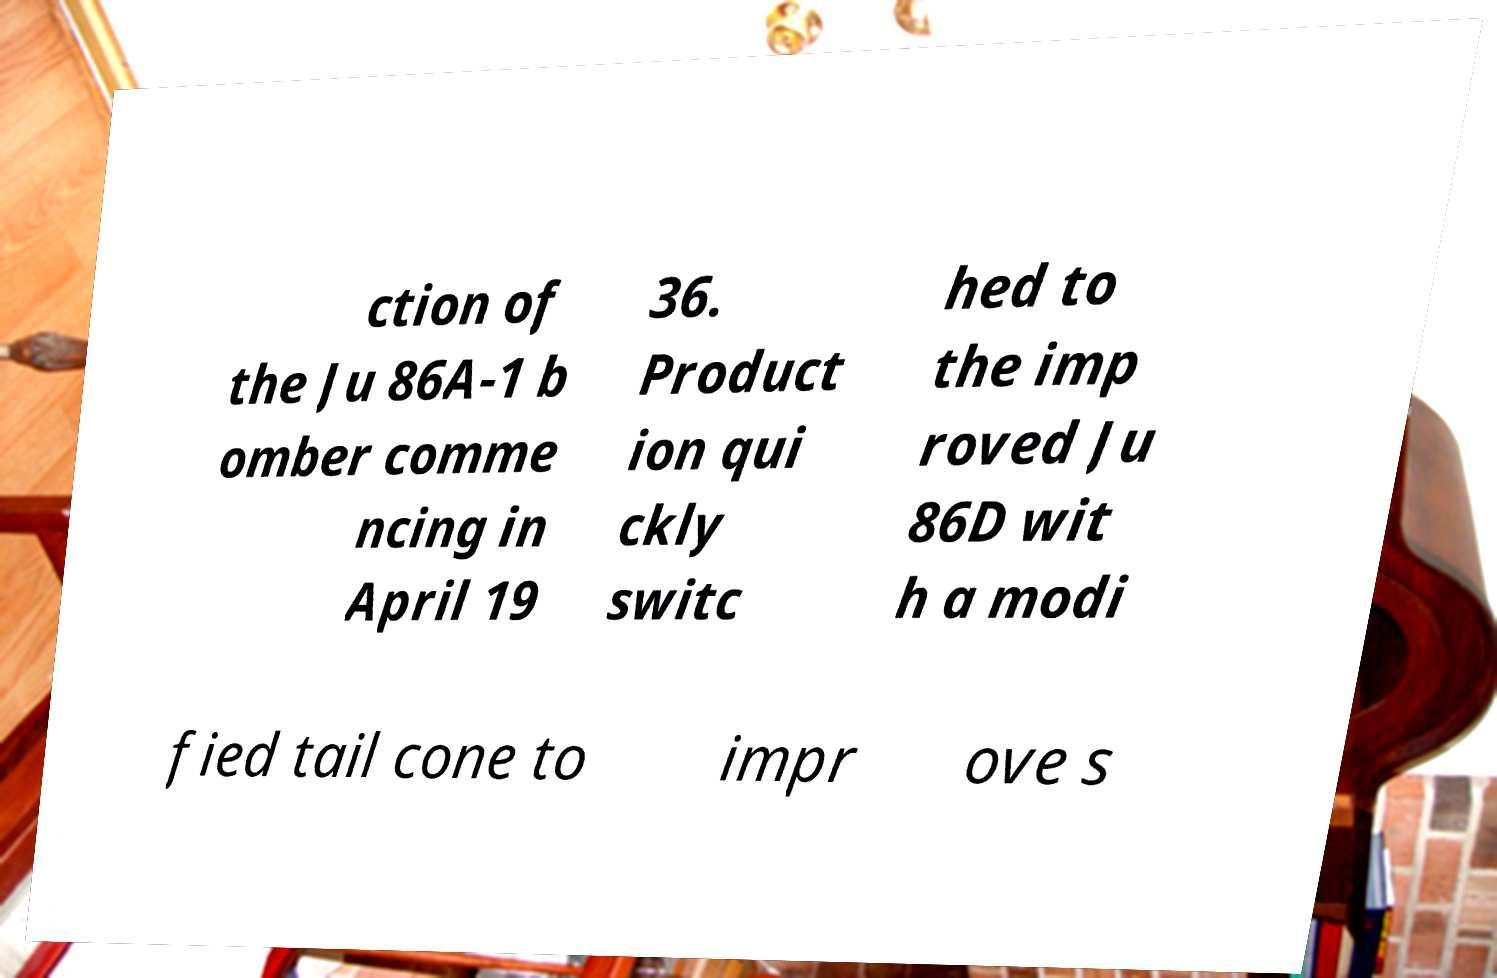I need the written content from this picture converted into text. Can you do that? ction of the Ju 86A-1 b omber comme ncing in April 19 36. Product ion qui ckly switc hed to the imp roved Ju 86D wit h a modi fied tail cone to impr ove s 